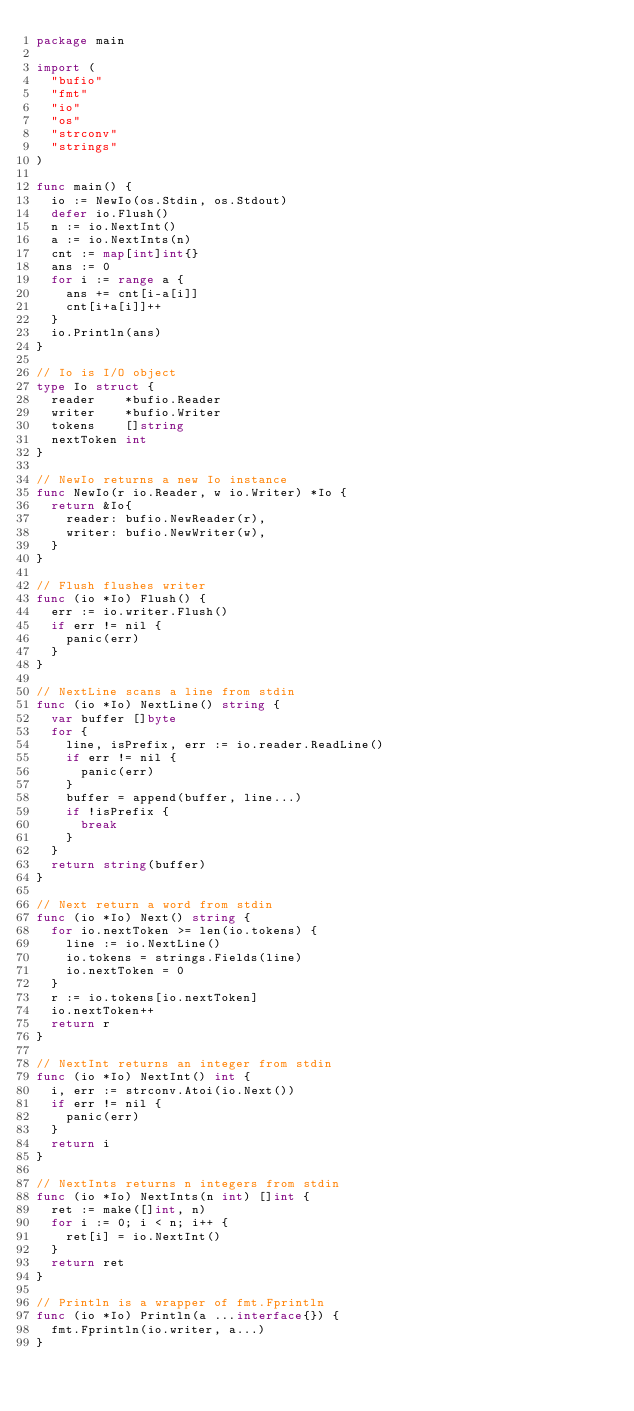<code> <loc_0><loc_0><loc_500><loc_500><_Go_>package main

import (
	"bufio"
	"fmt"
	"io"
	"os"
	"strconv"
	"strings"
)

func main() {
	io := NewIo(os.Stdin, os.Stdout)
	defer io.Flush()
	n := io.NextInt()
	a := io.NextInts(n)
	cnt := map[int]int{}
	ans := 0
	for i := range a {
		ans += cnt[i-a[i]]
		cnt[i+a[i]]++
	}
	io.Println(ans)
}

// Io is I/O object
type Io struct {
	reader    *bufio.Reader
	writer    *bufio.Writer
	tokens    []string
	nextToken int
}

// NewIo returns a new Io instance
func NewIo(r io.Reader, w io.Writer) *Io {
	return &Io{
		reader: bufio.NewReader(r),
		writer: bufio.NewWriter(w),
	}
}

// Flush flushes writer
func (io *Io) Flush() {
	err := io.writer.Flush()
	if err != nil {
		panic(err)
	}
}

// NextLine scans a line from stdin
func (io *Io) NextLine() string {
	var buffer []byte
	for {
		line, isPrefix, err := io.reader.ReadLine()
		if err != nil {
			panic(err)
		}
		buffer = append(buffer, line...)
		if !isPrefix {
			break
		}
	}
	return string(buffer)
}

// Next return a word from stdin
func (io *Io) Next() string {
	for io.nextToken >= len(io.tokens) {
		line := io.NextLine()
		io.tokens = strings.Fields(line)
		io.nextToken = 0
	}
	r := io.tokens[io.nextToken]
	io.nextToken++
	return r
}

// NextInt returns an integer from stdin
func (io *Io) NextInt() int {
	i, err := strconv.Atoi(io.Next())
	if err != nil {
		panic(err)
	}
	return i
}

// NextInts returns n integers from stdin
func (io *Io) NextInts(n int) []int {
	ret := make([]int, n)
	for i := 0; i < n; i++ {
		ret[i] = io.NextInt()
	}
	return ret
}

// Println is a wrapper of fmt.Fprintln
func (io *Io) Println(a ...interface{}) {
	fmt.Fprintln(io.writer, a...)
}
</code> 